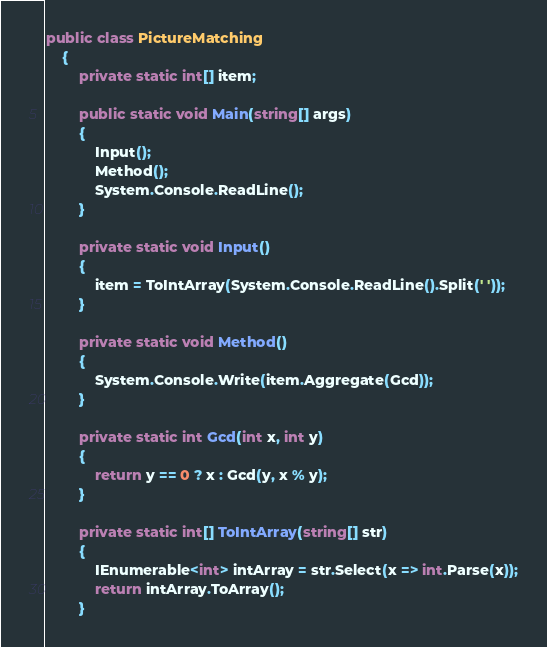<code> <loc_0><loc_0><loc_500><loc_500><_C#_>public class PictureMatching
    {
        private static int[] item;

        public static void Main(string[] args)
        {
            Input();
            Method();
            System.Console.ReadLine();
        }

        private static void Input()
        {
            item = ToIntArray(System.Console.ReadLine().Split(' '));
        }

        private static void Method()
        {
            System.Console.Write(item.Aggregate(Gcd));
        }

        private static int Gcd(int x, int y)
        {
            return y == 0 ? x : Gcd(y, x % y);
        }

        private static int[] ToIntArray(string[] str)
        {
            IEnumerable<int> intArray = str.Select(x => int.Parse(x));
            return intArray.ToArray();
        }</code> 